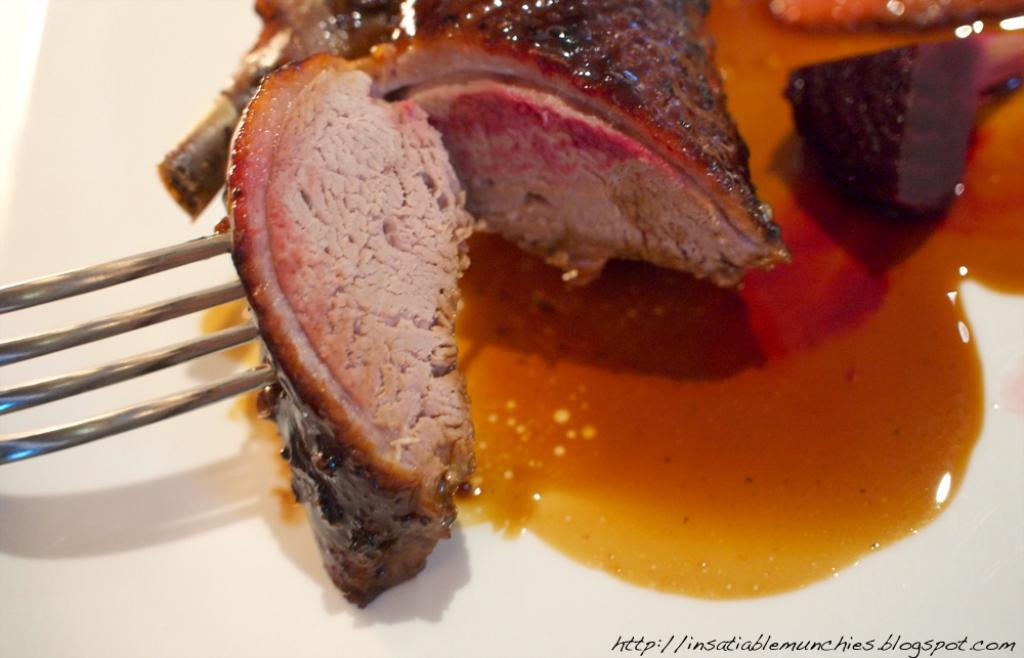What is the main food item visible in the image? There is a food item served in a plate in the image. What utensil is located on the left side of the image? There is a fork on the left side of the image. Where can text be found in the image? Text is located at the bottom towards the right side of the image. What type of baseball is being transported by the owner in the image? There is no baseball or owner present in the image. 